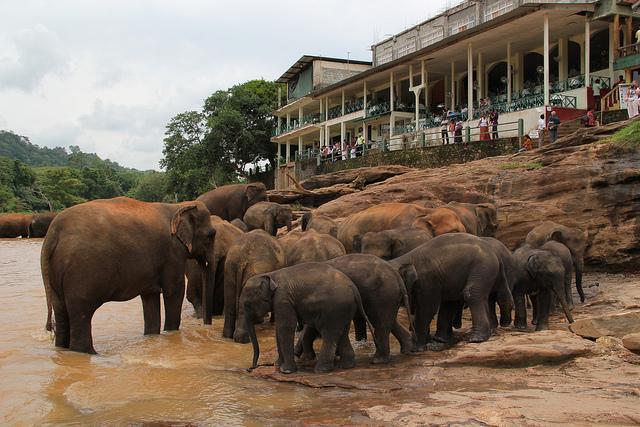What keeps the elephants out of the buildings?
Answer the question by selecting the correct answer among the 4 following choices and explain your choice with a short sentence. The answer should be formatted with the following format: `Answer: choice
Rationale: rationale.`
Options: Water, herders, noise, rocks. Answer: rocks.
Rationale: There is a visible rock barrier around the front of the buildings. a rock face this steep would not be possible for an elephant to climb. 